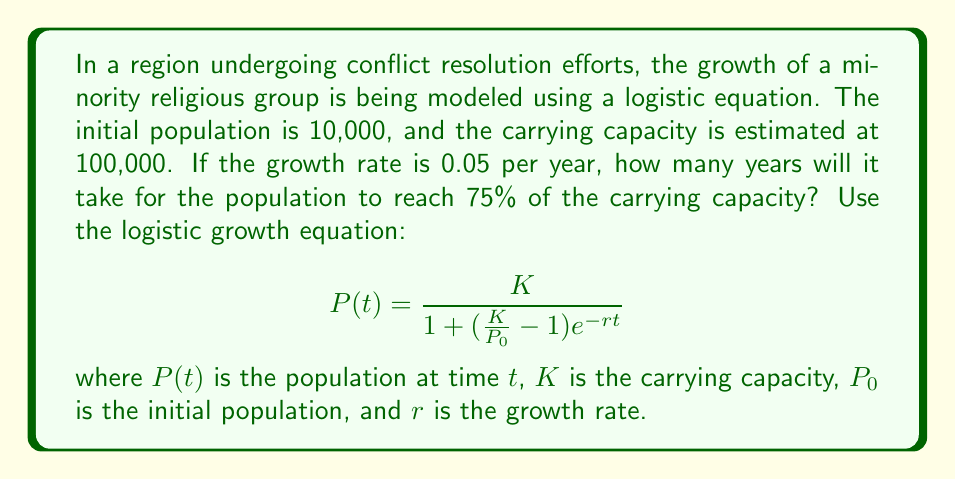Provide a solution to this math problem. To solve this problem, we'll follow these steps:

1) We're given:
   $K = 100,000$ (carrying capacity)
   $P_0 = 10,000$ (initial population)
   $r = 0.05$ (growth rate)
   
   We need to find $t$ when $P(t) = 0.75K = 75,000$

2) Substitute these values into the logistic equation:

   $$75,000 = \frac{100,000}{1 + (\frac{100,000}{10,000} - 1)e^{-0.05t}}$$

3) Simplify:

   $$75,000 = \frac{100,000}{1 + 9e^{-0.05t}}$$

4) Multiply both sides by the denominator:

   $$75,000(1 + 9e^{-0.05t}) = 100,000$$

5) Expand:

   $$75,000 + 675,000e^{-0.05t} = 100,000$$

6) Subtract 75,000 from both sides:

   $$675,000e^{-0.05t} = 25,000$$

7) Divide both sides by 675,000:

   $$e^{-0.05t} = \frac{1}{27}$$

8) Take the natural log of both sides:

   $$-0.05t = \ln(\frac{1}{27})$$

9) Divide both sides by -0.05:

   $$t = \frac{\ln(27)}{0.05} \approx 66.14$$

Therefore, it will take approximately 66.14 years for the population to reach 75% of the carrying capacity.
Answer: 66.14 years 